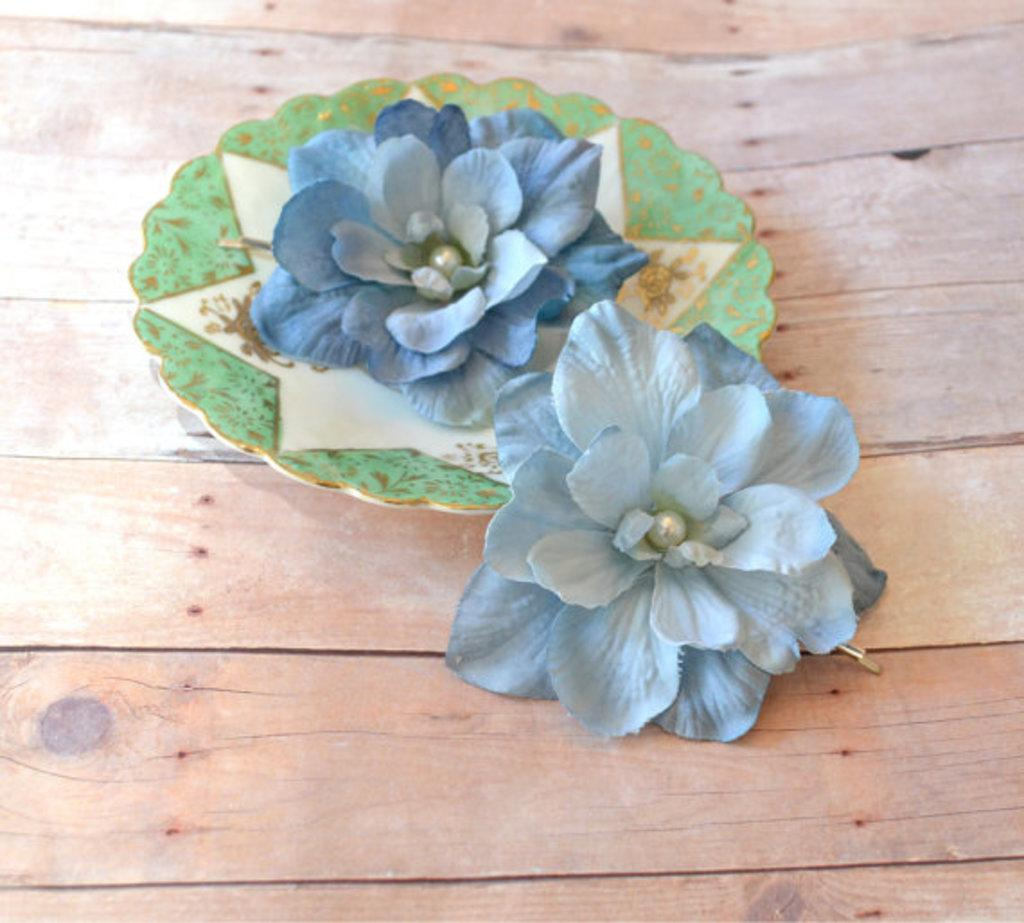What is the main subject in the center of the image? There is an artificial flower in the center of the image. How is the artificial flower displayed in the image? The artificial flower is placed on a plate. What can be seen in the foreground of the image? There is a flower in the foreground of the image. On what surface is the flower placed? The flower is kept on a surface. What type of glove is being used to support the artificial flower in the image? There is no glove present in the image, and the artificial flower is supported by a plate. 